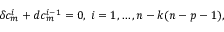<formula> <loc_0><loc_0><loc_500><loc_500>\delta c _ { m } ^ { i } + d c _ { m } ^ { i - 1 } = 0 , \, i = 1 , \dots , n - k ( n - p - 1 ) ,</formula> 